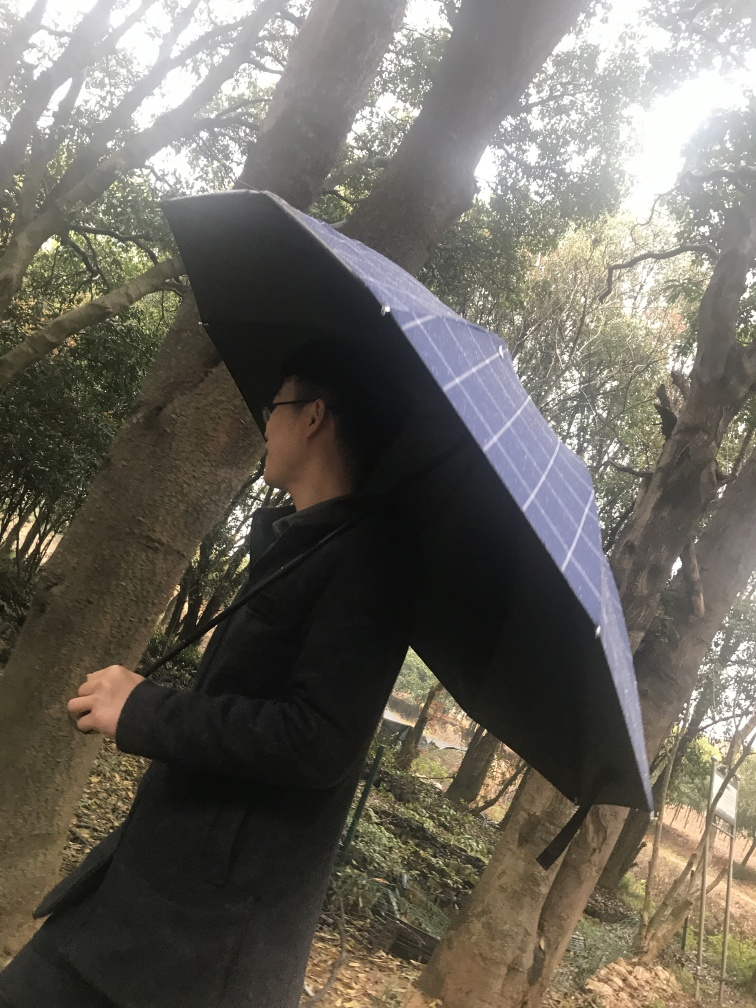What is the mood conveyed by the image and how does the setting contribute to it? The image conveys a contemplative or introspective mood, with the solitary figure and the natural, somewhat gloomy setting emphasizing a sense of solitude. The overcast sky and the shielding umbrella may also indicate a desire for shelter or reflection, away from the hectic pace of everyday life. 